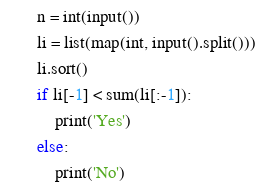<code> <loc_0><loc_0><loc_500><loc_500><_Python_>n = int(input())
li = list(map(int, input().split()))
li.sort()
if li[-1] < sum(li[:-1]):
    print('Yes')
else:
    print('No')
</code> 